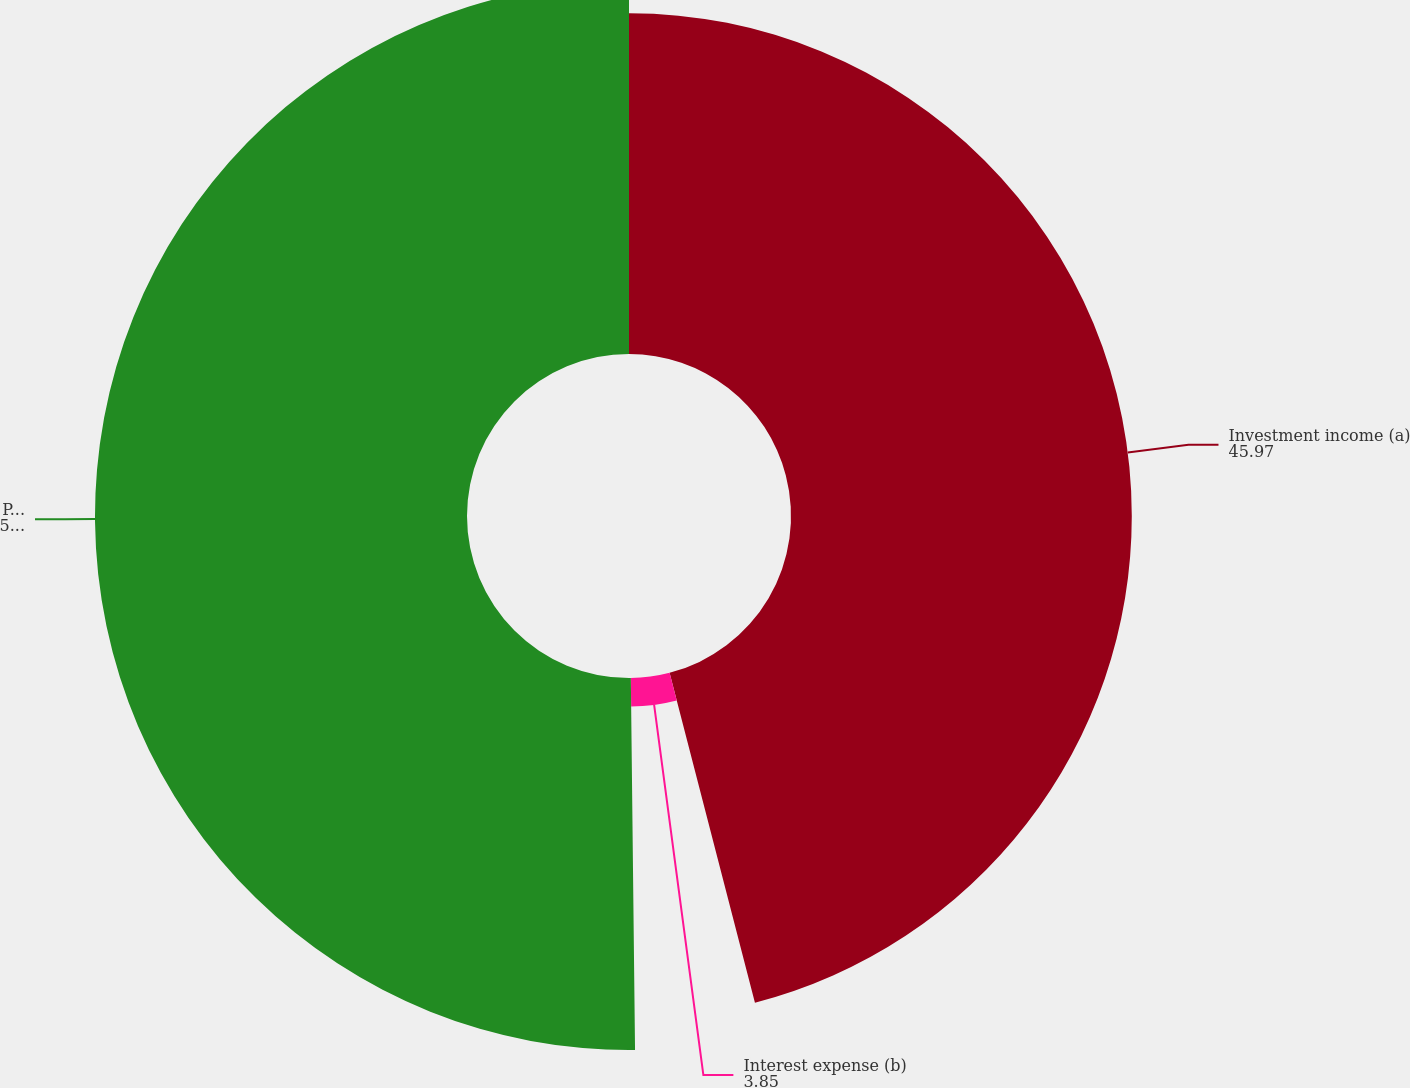<chart> <loc_0><loc_0><loc_500><loc_500><pie_chart><fcel>Investment income (a)<fcel>Interest expense (b)<fcel>Pretax<nl><fcel>45.97%<fcel>3.85%<fcel>50.18%<nl></chart> 